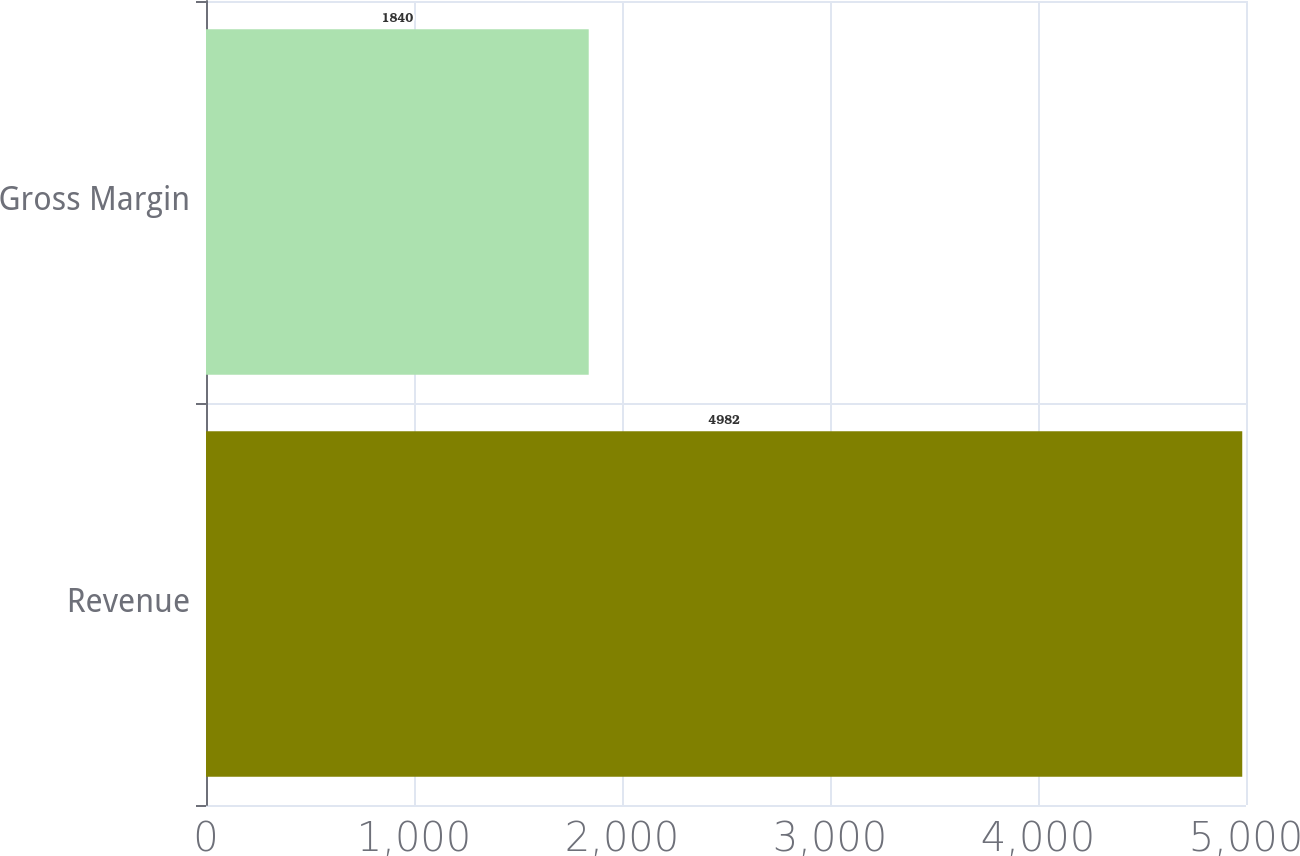Convert chart. <chart><loc_0><loc_0><loc_500><loc_500><bar_chart><fcel>Revenue<fcel>Gross Margin<nl><fcel>4982<fcel>1840<nl></chart> 